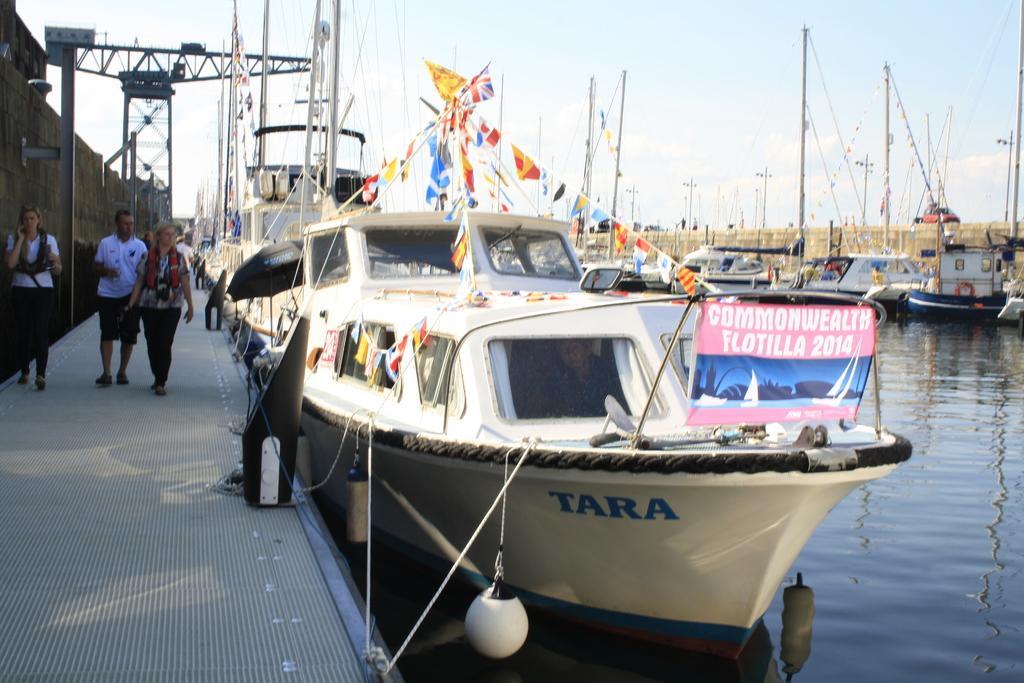How would you summarize this image in a sentence or two? In this image I can see a port area with the boats parked. I can see a walkway on the left hand side of the image. I can see three people walking In this way. I can see a wall beside them. I can see some metal objects behind them. I can see the sky at the top of the image. At the bottom of the image I can see the sky. 